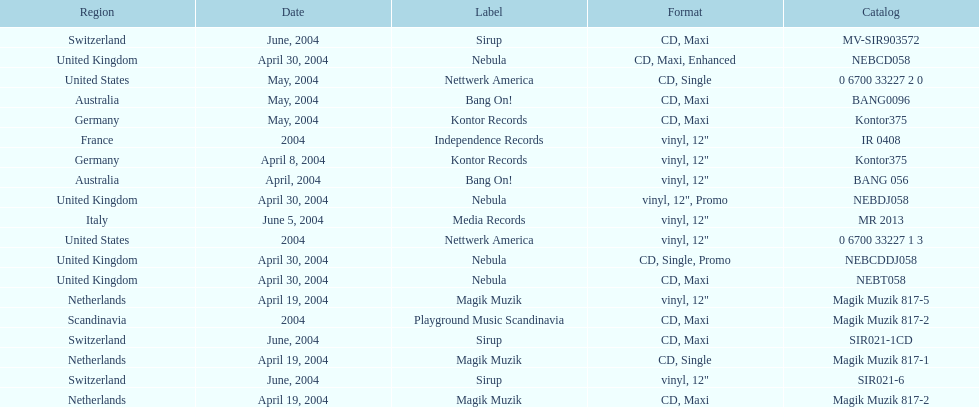What label was the only label to be used by france? Independence Records. 